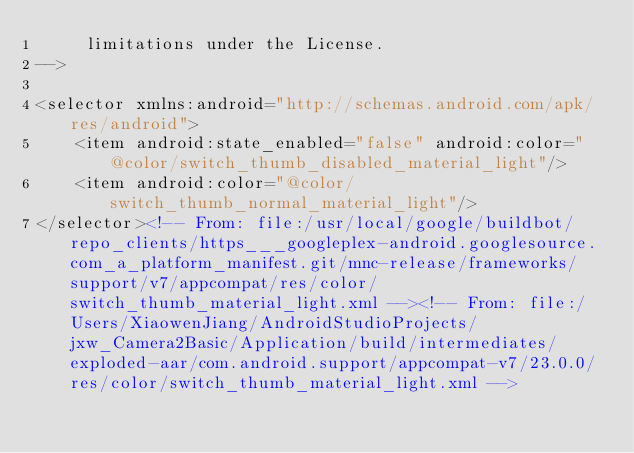<code> <loc_0><loc_0><loc_500><loc_500><_XML_>     limitations under the License.
-->

<selector xmlns:android="http://schemas.android.com/apk/res/android">
    <item android:state_enabled="false" android:color="@color/switch_thumb_disabled_material_light"/>
    <item android:color="@color/switch_thumb_normal_material_light"/>
</selector><!-- From: file:/usr/local/google/buildbot/repo_clients/https___googleplex-android.googlesource.com_a_platform_manifest.git/mnc-release/frameworks/support/v7/appcompat/res/color/switch_thumb_material_light.xml --><!-- From: file:/Users/XiaowenJiang/AndroidStudioProjects/jxw_Camera2Basic/Application/build/intermediates/exploded-aar/com.android.support/appcompat-v7/23.0.0/res/color/switch_thumb_material_light.xml --></code> 